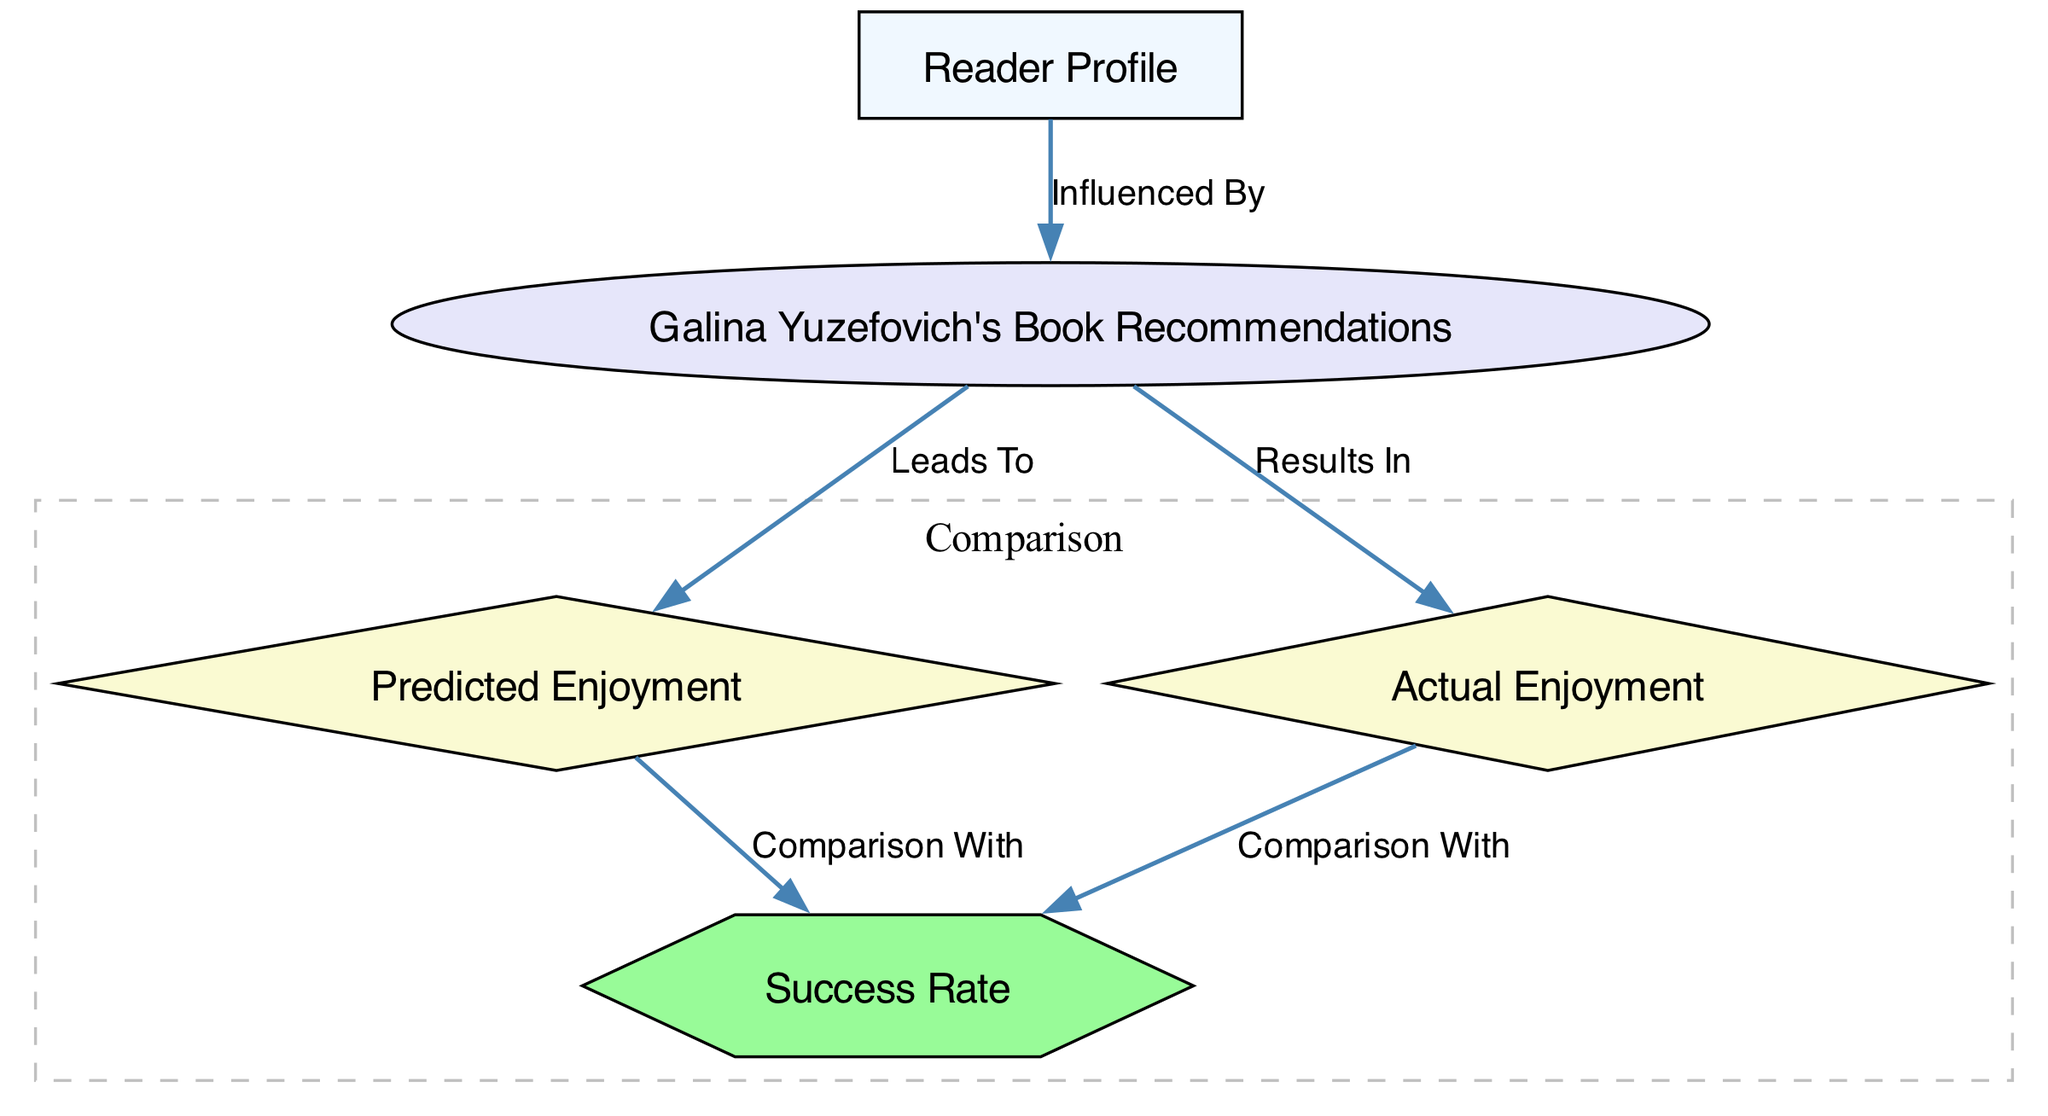What are the names of the two types of enjoyment in the diagram? The diagram specifies "Predicted Enjoyment" and "Actual Enjoyment" as the two types of enjoyment.
Answer: Predicted Enjoyment, Actual Enjoyment How many nodes are there in the diagram? The diagram includes five nodes: Reader Profile, Galina Yuzefovich's Book Recommendations, Predicted Enjoyment, Actual Enjoyment, and Success Rate. Therefore, there are a total of five nodes.
Answer: 5 What shape is used for Galina Yuzefovich's Book Recommendations? The node representing Galina Yuzefovich's Book Recommendations is depicted as an ellipse in the diagram.
Answer: Ellipse Which node leads to Actual Enjoyment? The node "Galina Yuzefovich's Book Recommendations" directly leads to "Actual Enjoyment" based on the edge labeled "Results In."
Answer: Galina Yuzefovich's Book Recommendations Which types of nodes compare with the Success Rate? Both "Predicted Enjoyment" and "Actual Enjoyment" compare with the "Success Rate," as indicated by the edges labeled "Comparison With."
Answer: Predicted Enjoyment, Actual Enjoyment What is the relationship between Reader Profile and Book Recommendations? The diagram shows that the "Reader Profile" node is connected to "Galina Yuzefovich's Book Recommendations" with a label indicating that it is "Influenced By."
Answer: Influenced By Which two nodes are part of the comparison subgraph? The subgraph labeled "Comparison" includes the nodes "Predicted Enjoyment" and "Actual Enjoyment."
Answer: Predicted Enjoyment, Actual Enjoyment What shape is used for the Success Rate node? The Success Rate node is represented as a hexagon in the diagram.
Answer: Hexagon How does the diagram categorize the relationship between Predicted Enjoyment and Actual Enjoyment? The relationship between "Predicted Enjoyment" and "Actual Enjoyment" is categorized by their individual comparisons with the "Success Rate," meaning they are both compared to the same outcome.
Answer: Comparison with Success Rate 